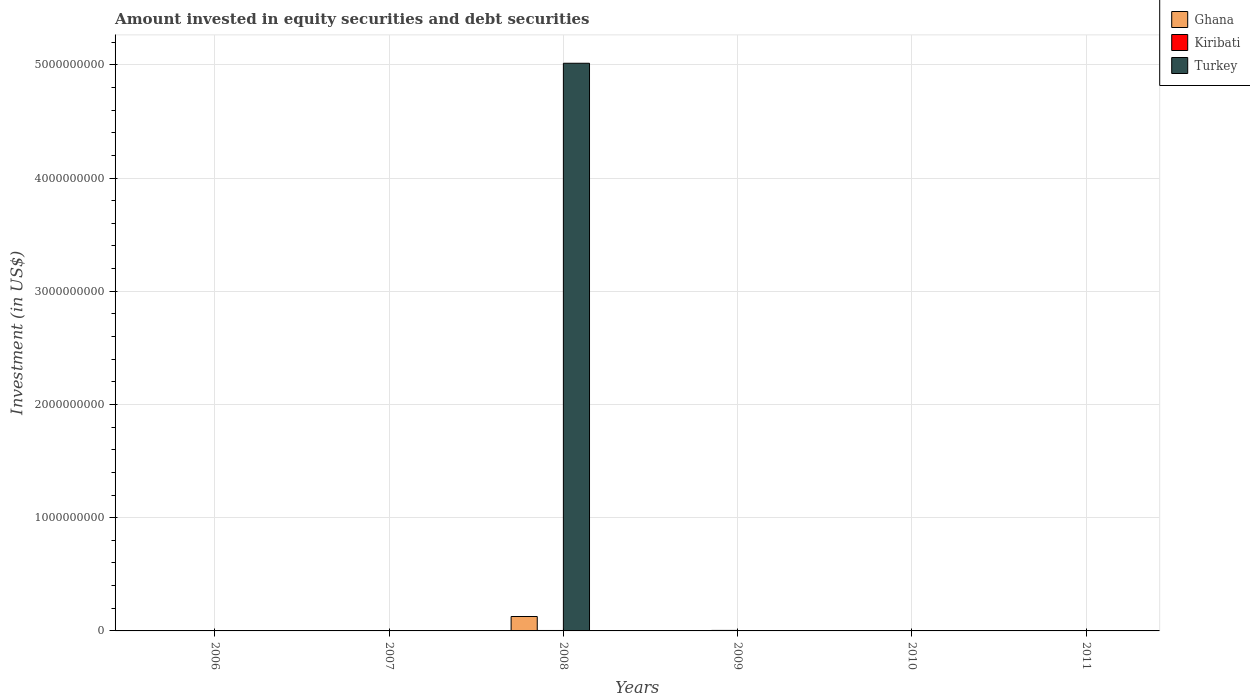How many different coloured bars are there?
Give a very brief answer. 3. Are the number of bars on each tick of the X-axis equal?
Make the answer very short. No. How many bars are there on the 6th tick from the left?
Make the answer very short. 0. What is the label of the 4th group of bars from the left?
Ensure brevity in your answer.  2009. Across all years, what is the maximum amount invested in equity securities and debt securities in Turkey?
Your answer should be very brief. 5.01e+09. Across all years, what is the minimum amount invested in equity securities and debt securities in Ghana?
Ensure brevity in your answer.  0. What is the total amount invested in equity securities and debt securities in Kiribati in the graph?
Provide a succinct answer. 1.28e+07. What is the difference between the amount invested in equity securities and debt securities in Kiribati in 2008 and the amount invested in equity securities and debt securities in Turkey in 2009?
Provide a succinct answer. 3.97e+06. What is the average amount invested in equity securities and debt securities in Turkey per year?
Offer a terse response. 8.36e+08. In the year 2008, what is the difference between the amount invested in equity securities and debt securities in Turkey and amount invested in equity securities and debt securities in Kiribati?
Your answer should be very brief. 5.01e+09. What is the ratio of the amount invested in equity securities and debt securities in Kiribati in 2009 to that in 2010?
Keep it short and to the point. 4.05. What is the difference between the highest and the second highest amount invested in equity securities and debt securities in Kiribati?
Offer a terse response. 4.67e+05. What is the difference between the highest and the lowest amount invested in equity securities and debt securities in Kiribati?
Your answer should be very brief. 4.43e+06. In how many years, is the amount invested in equity securities and debt securities in Turkey greater than the average amount invested in equity securities and debt securities in Turkey taken over all years?
Keep it short and to the point. 1. Is it the case that in every year, the sum of the amount invested in equity securities and debt securities in Turkey and amount invested in equity securities and debt securities in Kiribati is greater than the amount invested in equity securities and debt securities in Ghana?
Provide a succinct answer. No. How many bars are there?
Give a very brief answer. 6. Are all the bars in the graph horizontal?
Offer a very short reply. No. How many years are there in the graph?
Your answer should be compact. 6. Are the values on the major ticks of Y-axis written in scientific E-notation?
Keep it short and to the point. No. Does the graph contain any zero values?
Keep it short and to the point. Yes. Where does the legend appear in the graph?
Your answer should be compact. Top right. What is the title of the graph?
Keep it short and to the point. Amount invested in equity securities and debt securities. What is the label or title of the Y-axis?
Keep it short and to the point. Investment (in US$). What is the Investment (in US$) of Turkey in 2006?
Make the answer very short. 0. What is the Investment (in US$) in Ghana in 2007?
Offer a terse response. 0. What is the Investment (in US$) in Kiribati in 2007?
Your response must be concise. 3.34e+06. What is the Investment (in US$) in Ghana in 2008?
Offer a terse response. 1.27e+08. What is the Investment (in US$) of Kiribati in 2008?
Your answer should be compact. 3.97e+06. What is the Investment (in US$) of Turkey in 2008?
Your answer should be very brief. 5.01e+09. What is the Investment (in US$) in Ghana in 2009?
Provide a succinct answer. 0. What is the Investment (in US$) in Kiribati in 2009?
Your answer should be compact. 4.43e+06. What is the Investment (in US$) in Turkey in 2009?
Your answer should be compact. 0. What is the Investment (in US$) in Ghana in 2010?
Offer a very short reply. 0. What is the Investment (in US$) of Kiribati in 2010?
Offer a terse response. 1.10e+06. What is the Investment (in US$) in Turkey in 2010?
Offer a terse response. 0. What is the Investment (in US$) of Ghana in 2011?
Your answer should be very brief. 0. Across all years, what is the maximum Investment (in US$) of Ghana?
Your response must be concise. 1.27e+08. Across all years, what is the maximum Investment (in US$) in Kiribati?
Provide a succinct answer. 4.43e+06. Across all years, what is the maximum Investment (in US$) of Turkey?
Your answer should be very brief. 5.01e+09. Across all years, what is the minimum Investment (in US$) of Ghana?
Your answer should be very brief. 0. Across all years, what is the minimum Investment (in US$) of Kiribati?
Your response must be concise. 0. What is the total Investment (in US$) in Ghana in the graph?
Offer a terse response. 1.27e+08. What is the total Investment (in US$) in Kiribati in the graph?
Offer a terse response. 1.28e+07. What is the total Investment (in US$) of Turkey in the graph?
Your answer should be compact. 5.01e+09. What is the difference between the Investment (in US$) of Kiribati in 2007 and that in 2008?
Give a very brief answer. -6.28e+05. What is the difference between the Investment (in US$) in Kiribati in 2007 and that in 2009?
Provide a short and direct response. -1.09e+06. What is the difference between the Investment (in US$) in Kiribati in 2007 and that in 2010?
Keep it short and to the point. 2.24e+06. What is the difference between the Investment (in US$) in Kiribati in 2008 and that in 2009?
Make the answer very short. -4.67e+05. What is the difference between the Investment (in US$) of Kiribati in 2008 and that in 2010?
Provide a short and direct response. 2.87e+06. What is the difference between the Investment (in US$) in Kiribati in 2009 and that in 2010?
Give a very brief answer. 3.34e+06. What is the difference between the Investment (in US$) in Kiribati in 2007 and the Investment (in US$) in Turkey in 2008?
Offer a very short reply. -5.01e+09. What is the difference between the Investment (in US$) of Ghana in 2008 and the Investment (in US$) of Kiribati in 2009?
Offer a terse response. 1.23e+08. What is the difference between the Investment (in US$) in Ghana in 2008 and the Investment (in US$) in Kiribati in 2010?
Keep it short and to the point. 1.26e+08. What is the average Investment (in US$) in Ghana per year?
Your answer should be compact. 2.12e+07. What is the average Investment (in US$) of Kiribati per year?
Your answer should be compact. 2.14e+06. What is the average Investment (in US$) in Turkey per year?
Make the answer very short. 8.36e+08. In the year 2008, what is the difference between the Investment (in US$) in Ghana and Investment (in US$) in Kiribati?
Your answer should be compact. 1.23e+08. In the year 2008, what is the difference between the Investment (in US$) of Ghana and Investment (in US$) of Turkey?
Your answer should be very brief. -4.89e+09. In the year 2008, what is the difference between the Investment (in US$) in Kiribati and Investment (in US$) in Turkey?
Your response must be concise. -5.01e+09. What is the ratio of the Investment (in US$) in Kiribati in 2007 to that in 2008?
Offer a very short reply. 0.84. What is the ratio of the Investment (in US$) in Kiribati in 2007 to that in 2009?
Make the answer very short. 0.75. What is the ratio of the Investment (in US$) of Kiribati in 2007 to that in 2010?
Keep it short and to the point. 3.05. What is the ratio of the Investment (in US$) of Kiribati in 2008 to that in 2009?
Provide a short and direct response. 0.89. What is the ratio of the Investment (in US$) in Kiribati in 2008 to that in 2010?
Offer a terse response. 3.62. What is the ratio of the Investment (in US$) of Kiribati in 2009 to that in 2010?
Provide a succinct answer. 4.05. What is the difference between the highest and the second highest Investment (in US$) in Kiribati?
Offer a terse response. 4.67e+05. What is the difference between the highest and the lowest Investment (in US$) of Ghana?
Ensure brevity in your answer.  1.27e+08. What is the difference between the highest and the lowest Investment (in US$) in Kiribati?
Your response must be concise. 4.43e+06. What is the difference between the highest and the lowest Investment (in US$) in Turkey?
Offer a terse response. 5.01e+09. 